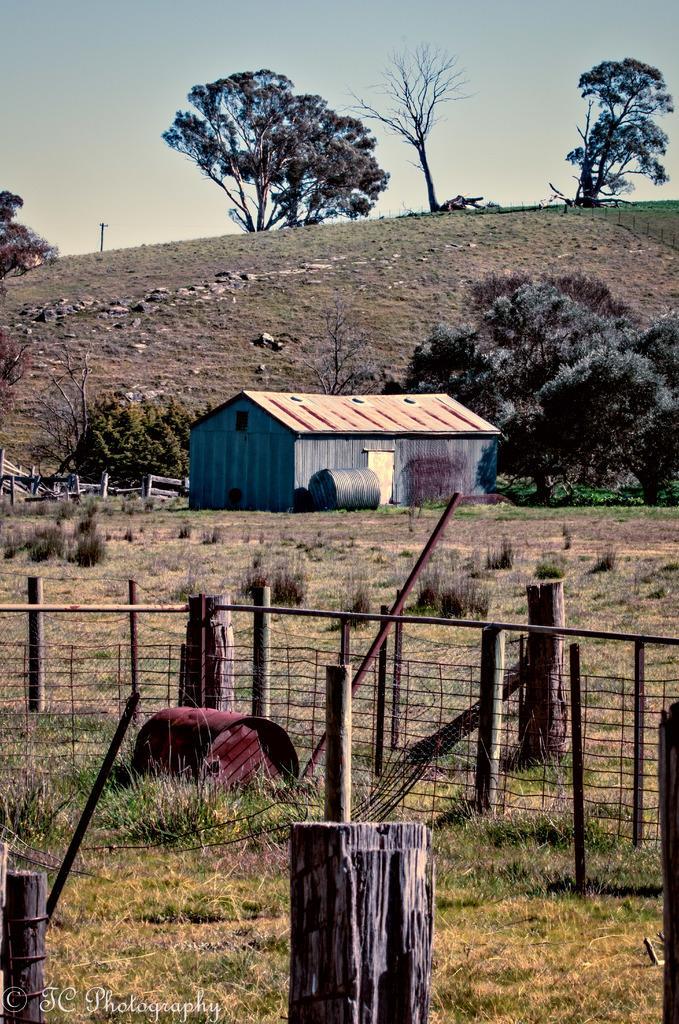Could you give a brief overview of what you see in this image? In this image, we can see a house, trees, plants, wooden objects, mesh, rods, few objects and grass. On the left side bottom corner, we can see a watermark. Top of the image, we can see the sky and hill. 